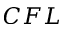<formula> <loc_0><loc_0><loc_500><loc_500>C F L</formula> 